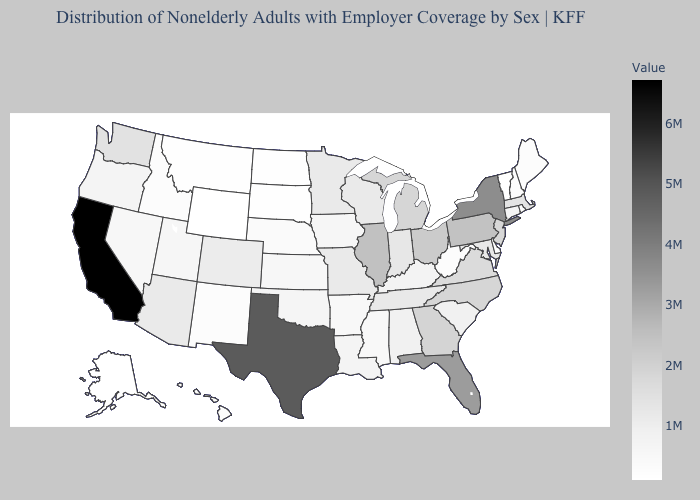Among the states that border Minnesota , which have the lowest value?
Concise answer only. North Dakota. Does Wyoming have the lowest value in the West?
Short answer required. Yes. Which states hav the highest value in the Northeast?
Write a very short answer. New York. Among the states that border Indiana , does Michigan have the highest value?
Short answer required. No. Among the states that border Vermont , does New Hampshire have the lowest value?
Answer briefly. Yes. Does Hawaii have the lowest value in the West?
Quick response, please. No. 